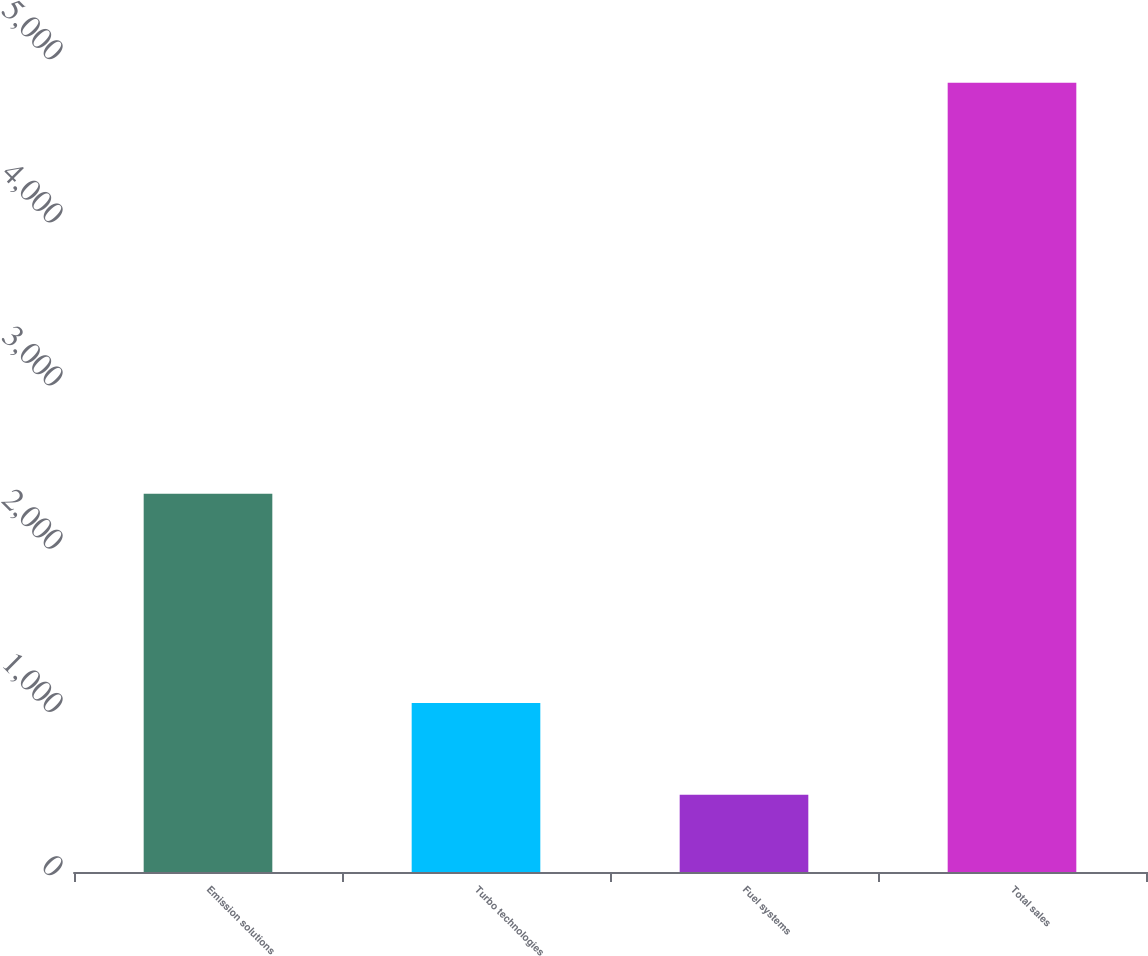<chart> <loc_0><loc_0><loc_500><loc_500><bar_chart><fcel>Emission solutions<fcel>Turbo technologies<fcel>Fuel systems<fcel>Total sales<nl><fcel>2317<fcel>1036<fcel>473<fcel>4836<nl></chart> 